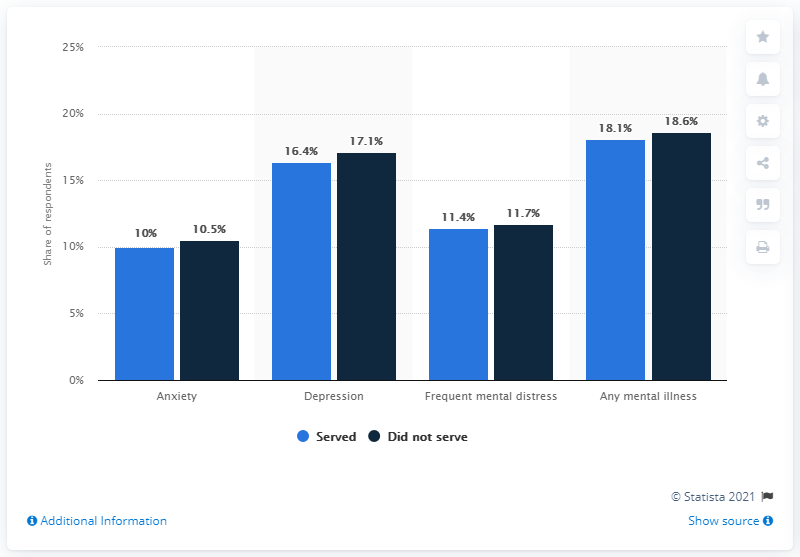Highlight a few significant elements in this photo. Frequent mental distress has the least difference between those who have been served and those who have not been served. In the United States, it is estimated that approximately 10% of individuals who have served in the military have experienced anxiety. 